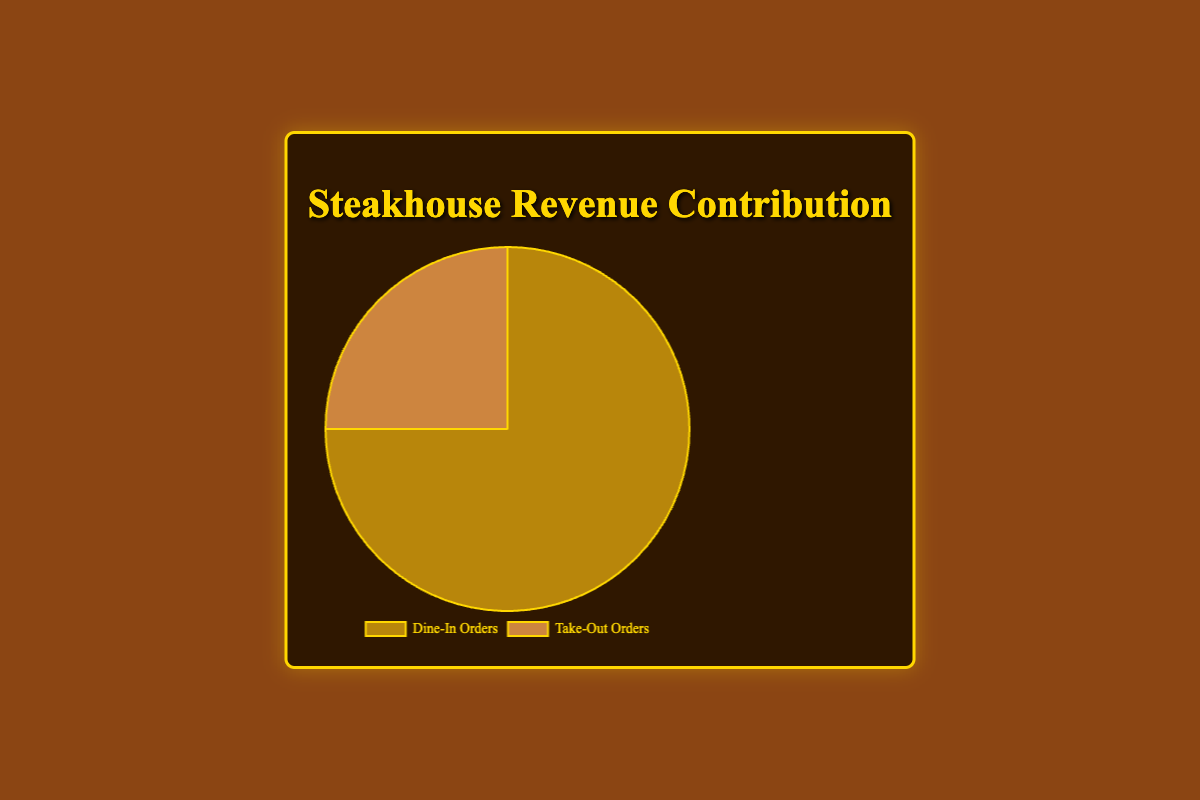Which revenue source contributes the largest share? The pie chart shows that "Dine-In Orders" contribute 75% while "Take-Out Orders" contributes 25%. Therefore, "Dine-In Orders" contributes the largest share.
Answer: Dine-In Orders What percentage of revenue comes from take-out orders? According to the pie chart, "Take-Out Orders" contribute 25% to the total revenue.
Answer: 25% How much more revenue does dine-in generate compared to take-out? (as a percentage) The pie chart indicates that dine-in generates 75% and take-out generates 25%. The difference is 75% - 25% = 50%.
Answer: 50% What is the ratio of dine-in revenue to take-out revenue? The revenue contributions are 75% for dine-in and 25% for take-out. The ratio of dine-in to take-out is 75:25, which simplifies to 3:1.
Answer: 3:1 What fraction of the total revenue comes from dine-in orders? The pie chart shows that dine-in orders contribute 75% to the total revenue, which is equivalent to the fraction 75/100 or 3/4.
Answer: 3/4 If the total revenue is $100,000, how much revenue comes from take-out orders? Take-out orders contribute 25% to the total revenue. Therefore, 25% of $100,000 is calculated as 0.25 * $100,000 = $25,000.
Answer: $25,000 If the total revenue is $80,000, how much does dine-in contribute in dollars? Dine-in orders contribute 75% to the total revenue. Therefore, 75% of $80,000 is calculated as 0.75 * $80,000 = $60,000.
Answer: $60,000 How does the visual representation indicate the larger revenue category? The pie chart segment for "Dine-In Orders" is visually larger and occupies more space (75%) compared to the "Take-Out Orders" segment (25%).
Answer: Larger segment for Dine-In Orders Which segment in the pie chart has a smaller slice and what does it represent? The smaller segment of the pie chart represents "Take-Out Orders," which contributes 25% of the total revenue.
Answer: Take-Out Orders 